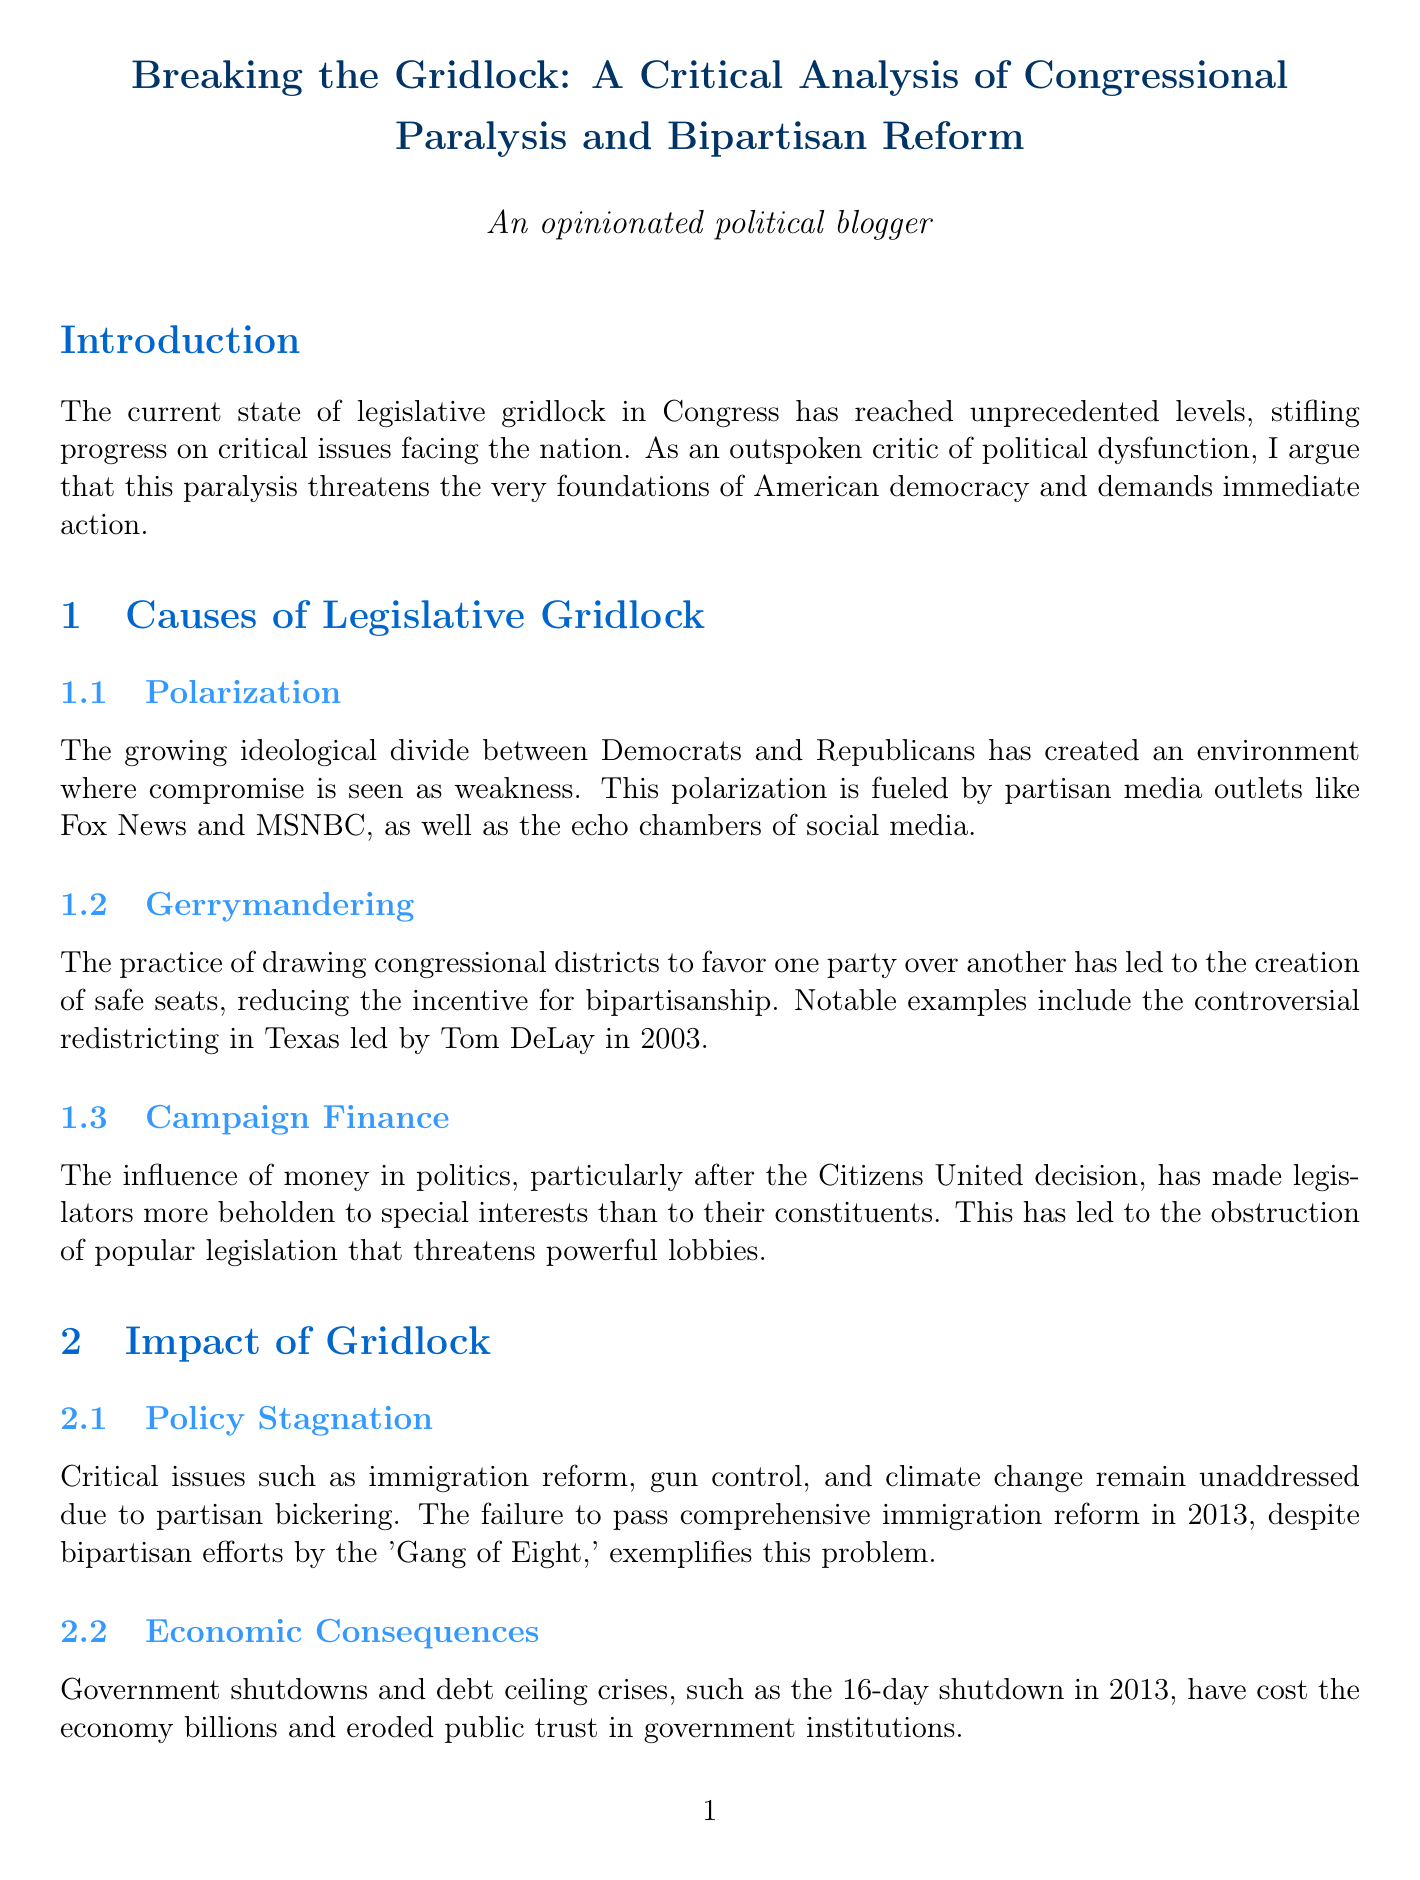What is the title of the report? The title is the main heading of the document introduced at the beginning, which summarizes the focus of the analysis.
Answer: Breaking the Gridlock: A Critical Analysis of Congressional Paralysis and Bipartisan Reform What year did Maine adopt ranked-choice voting? This is a specific piece of information mentioned in the proposed reforms section that provides an example of electoral reform.
Answer: 2018 Who are the prominent Democrats advocating for filibuster reform? This question requires identifying key individuals mentioned in the context of political reform mentioned in the document.
Answer: Elizabeth Warren and Bernie Sanders What is one major critical issue stalled due to gridlock? This asks for an example of a policy area affected by legislative stalemate discussed under the impact of gridlock.
Answer: Immigration reform What is one proposed measure to reduce the influence of money in politics? This requires connecting specific reforms suggested in the document related to campaign finance.
Answer: Overturning Citizens United How does gerrymandering affect bipartisanship? This assesses understanding of the relationship between gerrymandering practices and their consequences on political collaboration mentioned in the causes of gridlock.
Answer: It reduces the incentive for bipartisanship What is the focus of the Problem Solvers Caucus? This examines understanding of what bipartisan groups aim to achieve as noted in the proposed reforms section.
Answer: Foster collaboration across party lines What are two types of consequences of gridlock mentioned? This question asks for examples of the broader implications of legislative inaction outlined in the impact section.
Answer: Economic consequences and policy stagnation 